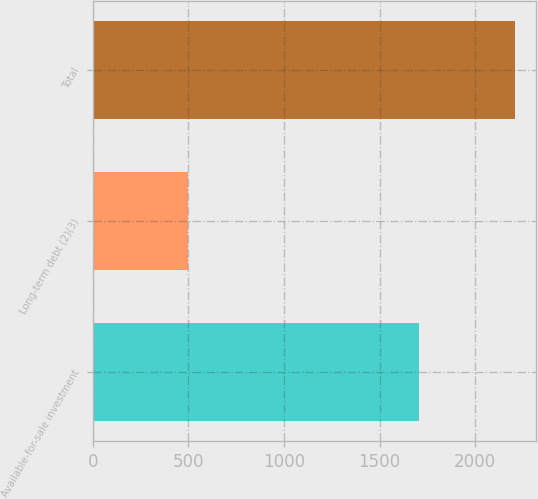Convert chart. <chart><loc_0><loc_0><loc_500><loc_500><bar_chart><fcel>Available-for-sale investment<fcel>Long-term debt (2)(3)<fcel>Total<nl><fcel>1707<fcel>500<fcel>2207<nl></chart> 